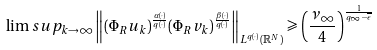Convert formula to latex. <formula><loc_0><loc_0><loc_500><loc_500>\lim s u p _ { k \to \infty } \left \| ( \Phi _ { R } u _ { k } ) ^ { \frac { \alpha ( \cdot ) } { q ( \cdot ) } } ( \Phi _ { R } v _ { k } ) ^ { \frac { \beta ( \cdot ) } { q ( \cdot ) } } \right \| _ { L ^ { q ( \cdot ) } ( \mathbb { R } ^ { N } ) } \geqslant \left ( \frac { \nu _ { \infty } } { 4 } \right ) ^ { \frac { 1 } { q _ { \infty } - \overline { \epsilon } } }</formula> 